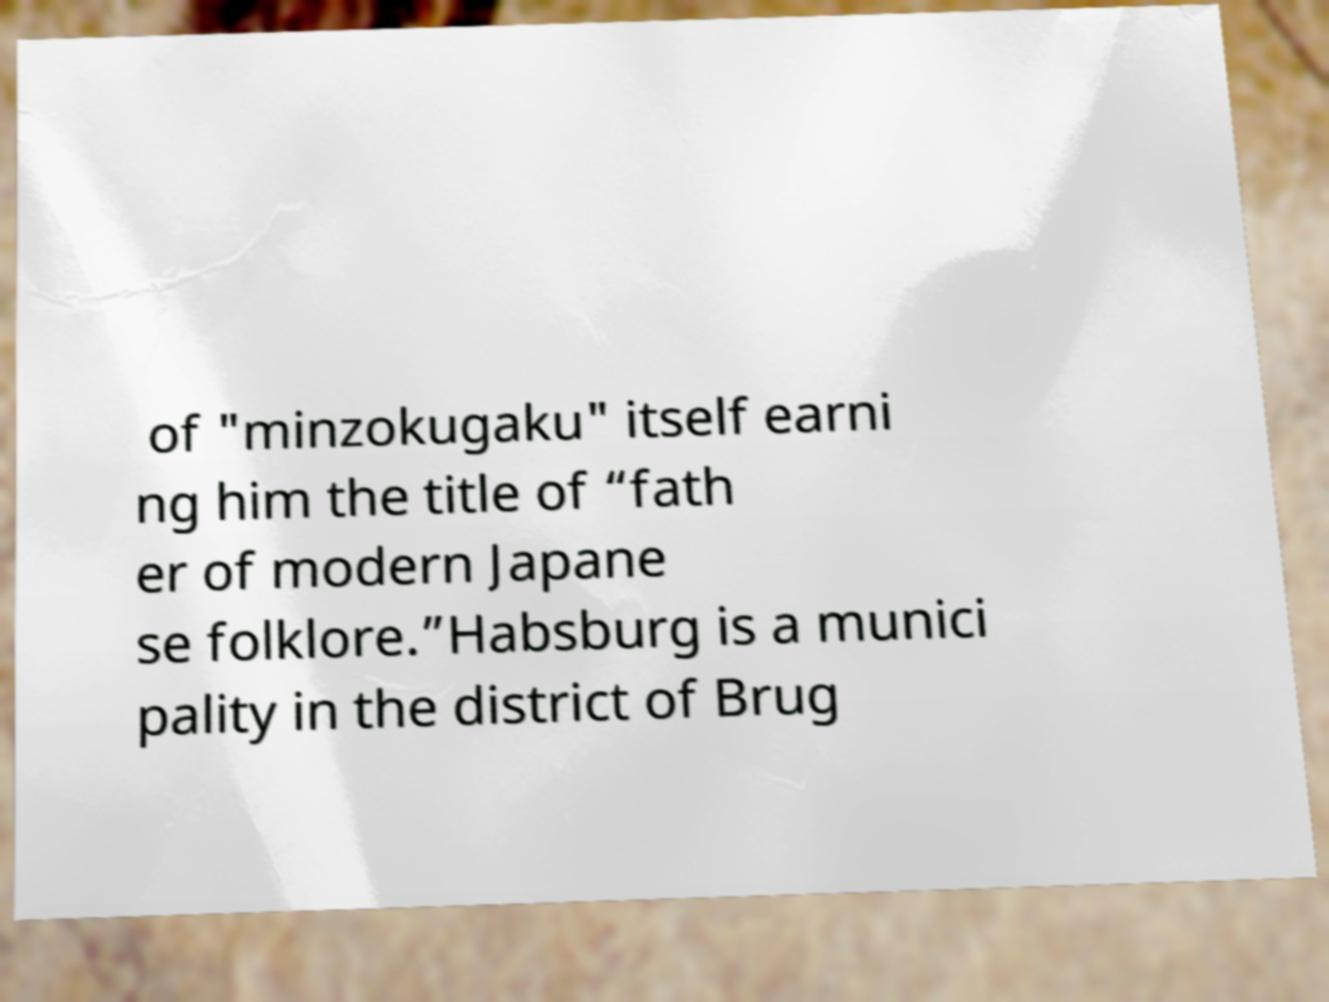Can you accurately transcribe the text from the provided image for me? of "minzokugaku" itself earni ng him the title of “fath er of modern Japane se folklore.”Habsburg is a munici pality in the district of Brug 